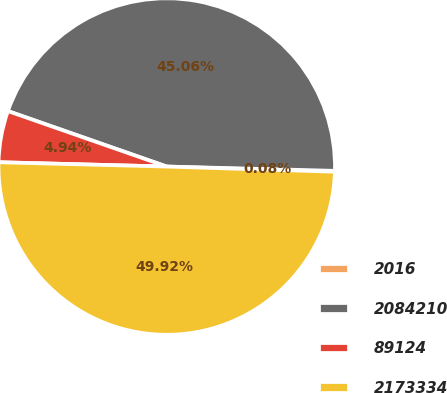Convert chart. <chart><loc_0><loc_0><loc_500><loc_500><pie_chart><fcel>2016<fcel>2084210<fcel>89124<fcel>2173334<nl><fcel>0.08%<fcel>45.06%<fcel>4.94%<fcel>49.92%<nl></chart> 